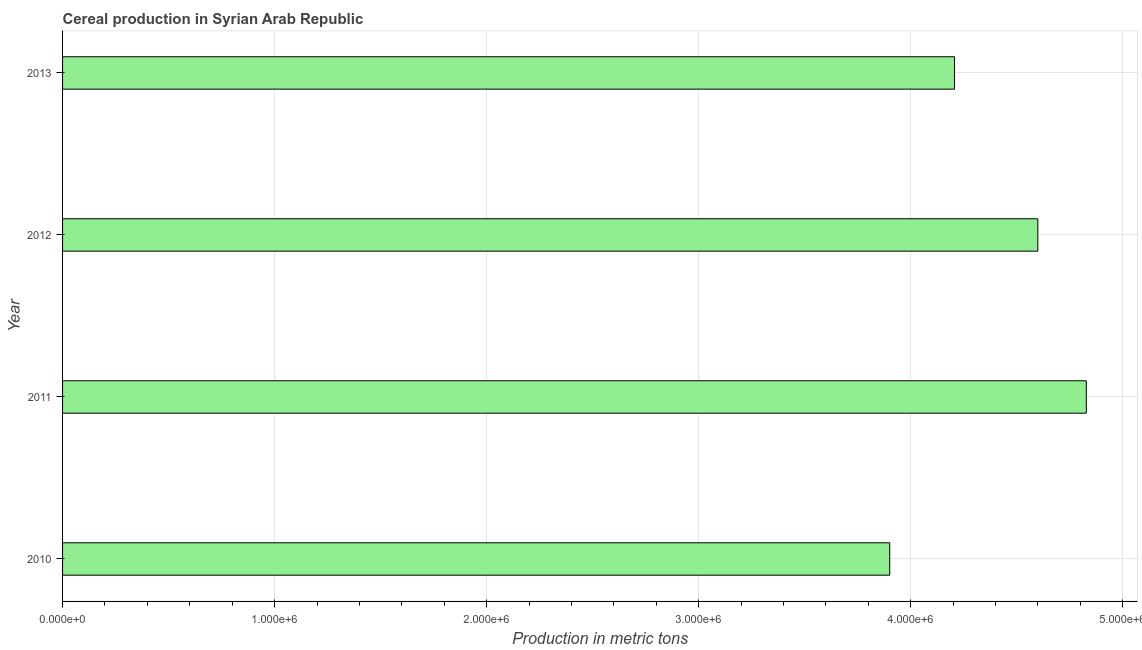Does the graph contain any zero values?
Make the answer very short. No. What is the title of the graph?
Offer a terse response. Cereal production in Syrian Arab Republic. What is the label or title of the X-axis?
Offer a terse response. Production in metric tons. What is the cereal production in 2013?
Your answer should be very brief. 4.21e+06. Across all years, what is the maximum cereal production?
Make the answer very short. 4.83e+06. Across all years, what is the minimum cereal production?
Keep it short and to the point. 3.90e+06. What is the sum of the cereal production?
Make the answer very short. 1.75e+07. What is the difference between the cereal production in 2011 and 2013?
Keep it short and to the point. 6.21e+05. What is the average cereal production per year?
Make the answer very short. 4.38e+06. What is the median cereal production?
Make the answer very short. 4.40e+06. In how many years, is the cereal production greater than 1400000 metric tons?
Make the answer very short. 4. Do a majority of the years between 2011 and 2013 (inclusive) have cereal production greater than 3600000 metric tons?
Provide a succinct answer. Yes. What is the ratio of the cereal production in 2010 to that in 2012?
Make the answer very short. 0.85. Is the cereal production in 2010 less than that in 2011?
Keep it short and to the point. Yes. What is the difference between the highest and the second highest cereal production?
Ensure brevity in your answer.  2.29e+05. Is the sum of the cereal production in 2010 and 2013 greater than the maximum cereal production across all years?
Provide a short and direct response. Yes. What is the difference between the highest and the lowest cereal production?
Give a very brief answer. 9.27e+05. In how many years, is the cereal production greater than the average cereal production taken over all years?
Your answer should be compact. 2. How many bars are there?
Offer a terse response. 4. How many years are there in the graph?
Your answer should be very brief. 4. What is the Production in metric tons in 2010?
Your answer should be very brief. 3.90e+06. What is the Production in metric tons in 2011?
Provide a succinct answer. 4.83e+06. What is the Production in metric tons in 2012?
Make the answer very short. 4.60e+06. What is the Production in metric tons in 2013?
Your response must be concise. 4.21e+06. What is the difference between the Production in metric tons in 2010 and 2011?
Ensure brevity in your answer.  -9.27e+05. What is the difference between the Production in metric tons in 2010 and 2012?
Offer a very short reply. -6.99e+05. What is the difference between the Production in metric tons in 2010 and 2013?
Your answer should be very brief. -3.06e+05. What is the difference between the Production in metric tons in 2011 and 2012?
Give a very brief answer. 2.29e+05. What is the difference between the Production in metric tons in 2011 and 2013?
Give a very brief answer. 6.21e+05. What is the difference between the Production in metric tons in 2012 and 2013?
Ensure brevity in your answer.  3.93e+05. What is the ratio of the Production in metric tons in 2010 to that in 2011?
Your answer should be very brief. 0.81. What is the ratio of the Production in metric tons in 2010 to that in 2012?
Provide a short and direct response. 0.85. What is the ratio of the Production in metric tons in 2010 to that in 2013?
Make the answer very short. 0.93. What is the ratio of the Production in metric tons in 2011 to that in 2013?
Offer a very short reply. 1.15. What is the ratio of the Production in metric tons in 2012 to that in 2013?
Keep it short and to the point. 1.09. 